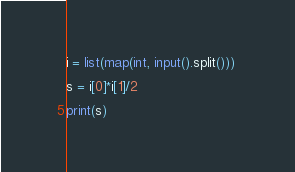Convert code to text. <code><loc_0><loc_0><loc_500><loc_500><_Python_>i = list(map(int, input().split())) 

s = i[0]*i[1]/2

print(s)

</code> 